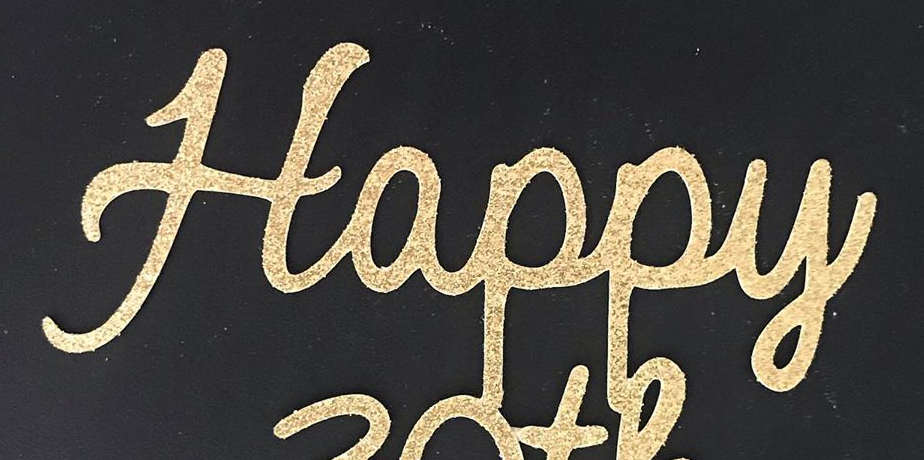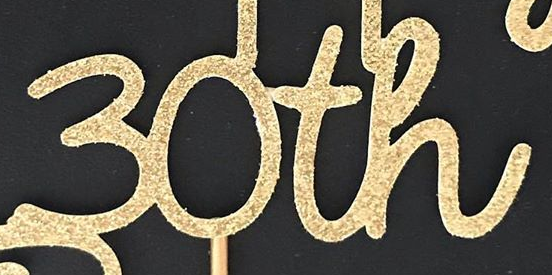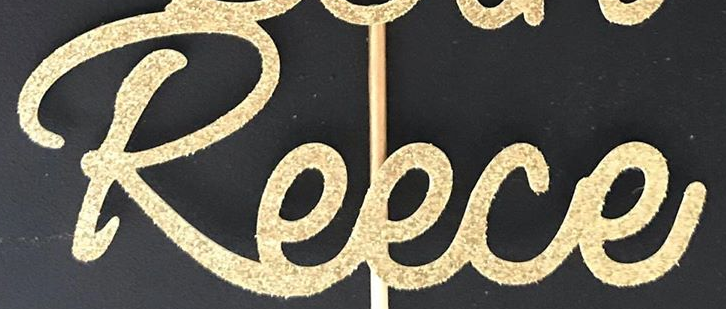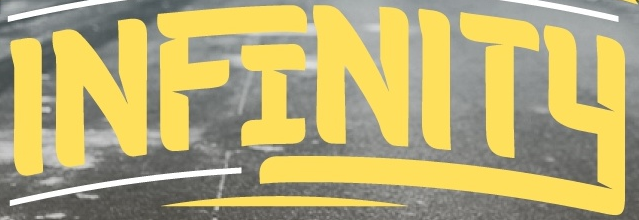Read the text from these images in sequence, separated by a semicolon. Happy; 30th; Reece; INFINITY 